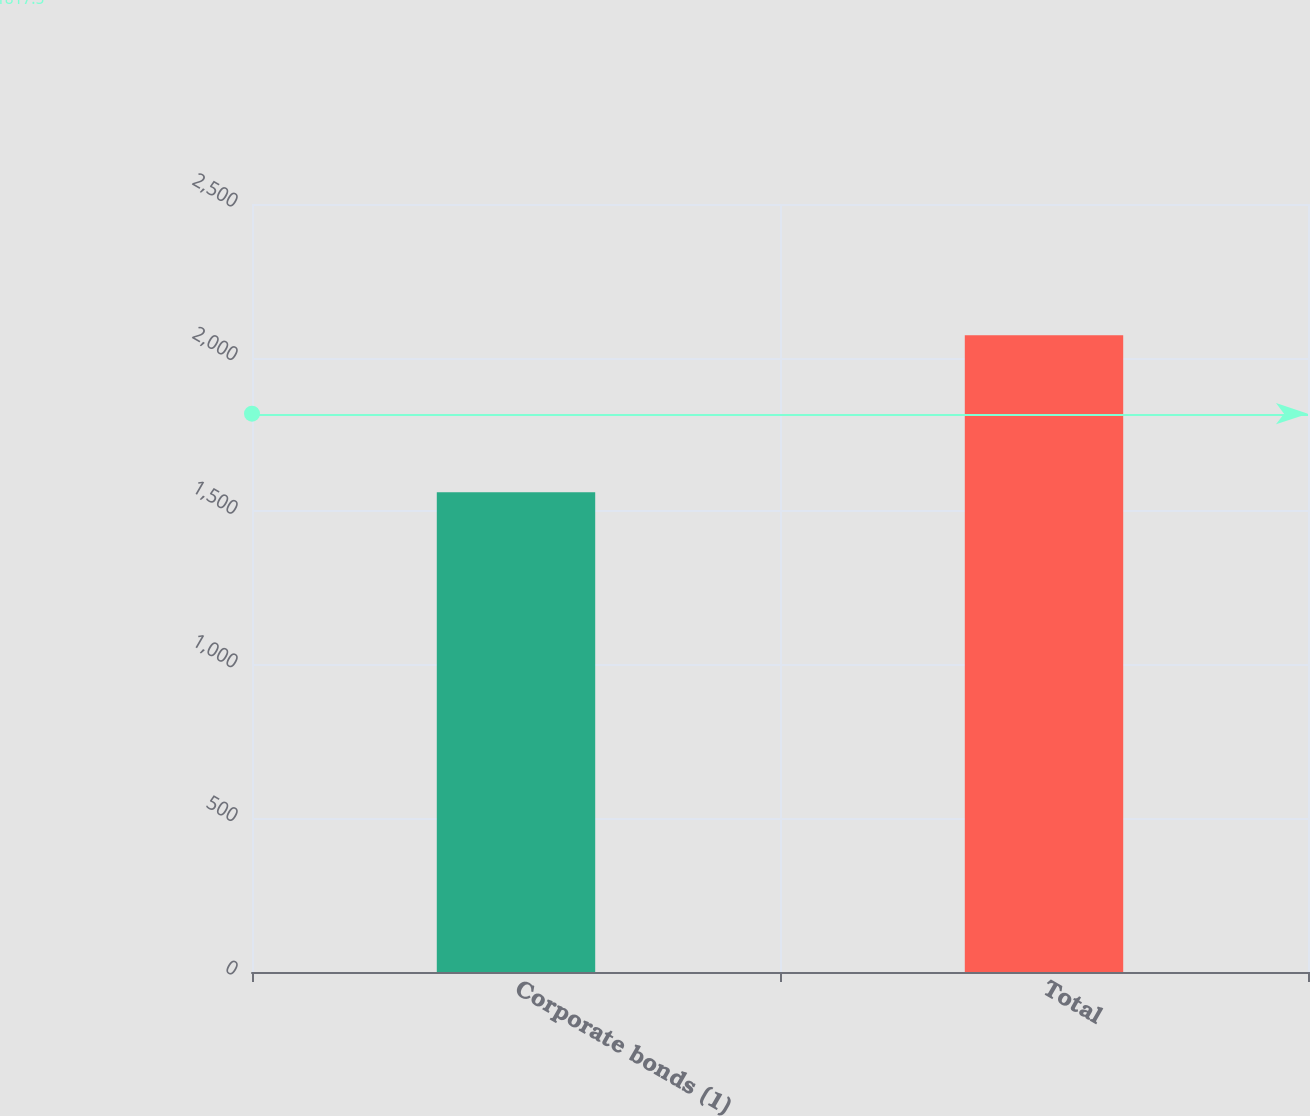Convert chart to OTSL. <chart><loc_0><loc_0><loc_500><loc_500><bar_chart><fcel>Corporate bonds (1)<fcel>Total<nl><fcel>1562<fcel>2073<nl></chart> 